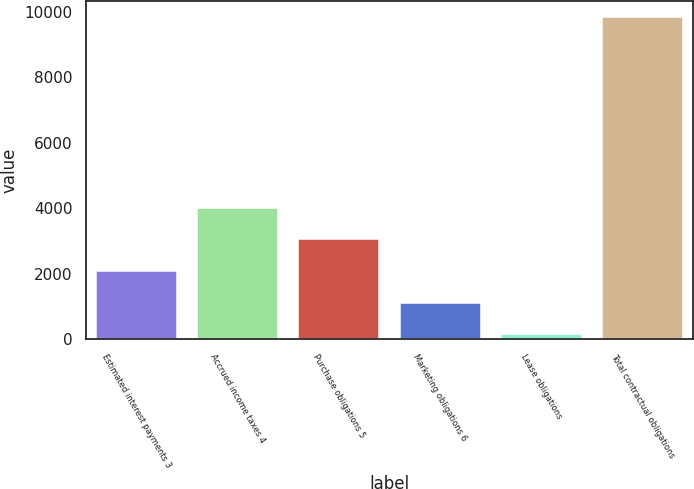Convert chart to OTSL. <chart><loc_0><loc_0><loc_500><loc_500><bar_chart><fcel>Estimated interest payments 3<fcel>Accrued income taxes 4<fcel>Purchase obligations 5<fcel>Marketing obligations 6<fcel>Lease obligations<fcel>Total contractual obligations<nl><fcel>2082.8<fcel>4022.6<fcel>3052.7<fcel>1112.9<fcel>143<fcel>9842<nl></chart> 